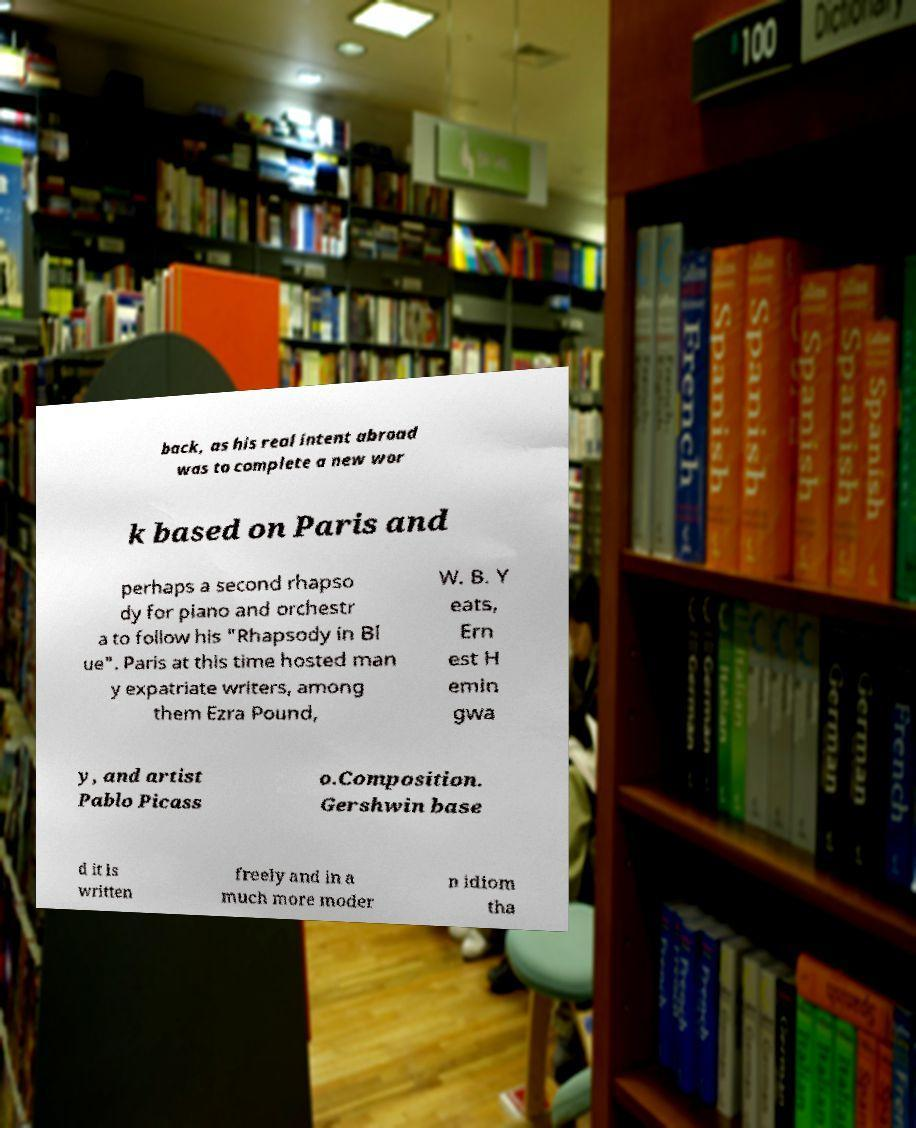Please read and relay the text visible in this image. What does it say? back, as his real intent abroad was to complete a new wor k based on Paris and perhaps a second rhapso dy for piano and orchestr a to follow his "Rhapsody in Bl ue". Paris at this time hosted man y expatriate writers, among them Ezra Pound, W. B. Y eats, Ern est H emin gwa y, and artist Pablo Picass o.Composition. Gershwin base d it is written freely and in a much more moder n idiom tha 